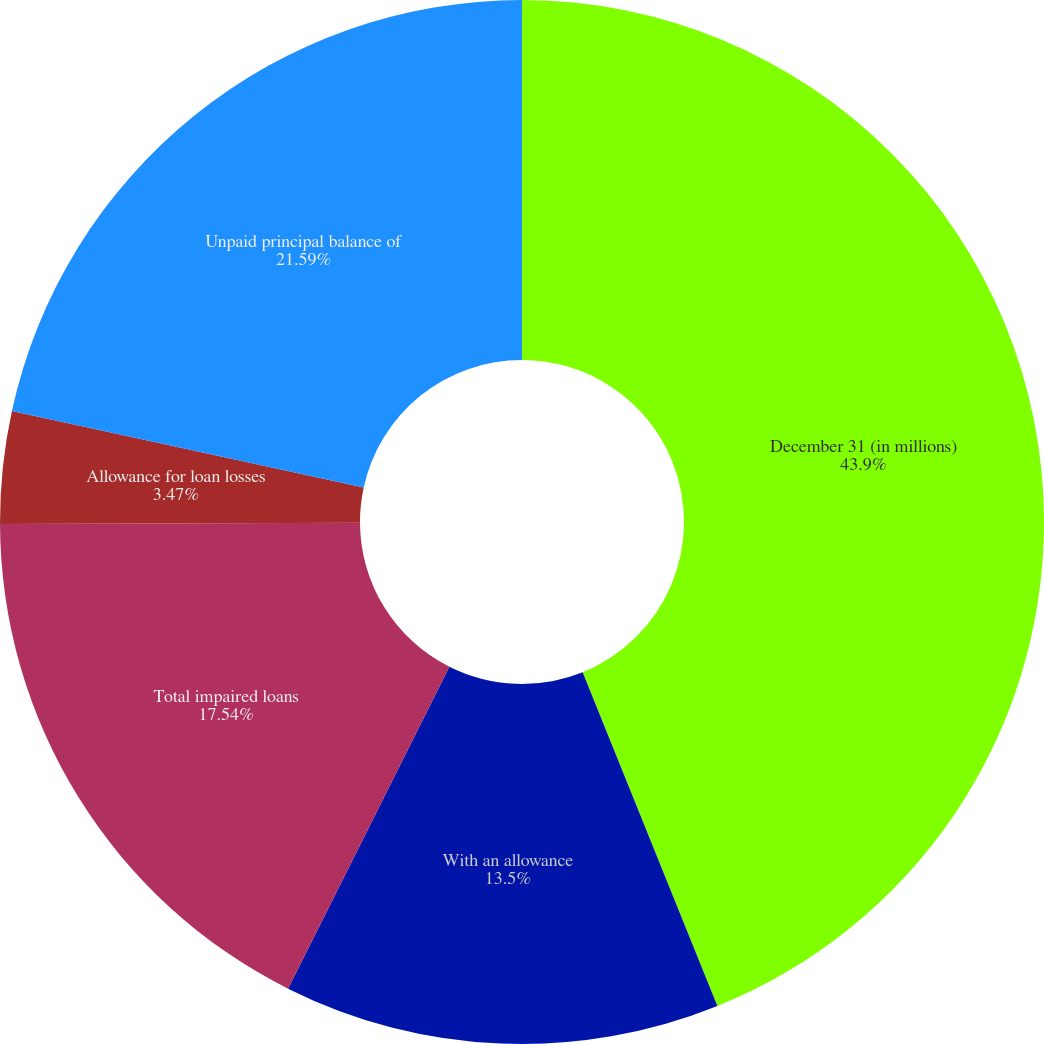Convert chart. <chart><loc_0><loc_0><loc_500><loc_500><pie_chart><fcel>December 31 (in millions)<fcel>With an allowance<fcel>Total impaired loans<fcel>Allowance for loan losses<fcel>Unpaid principal balance of<nl><fcel>43.89%<fcel>13.5%<fcel>17.54%<fcel>3.47%<fcel>21.59%<nl></chart> 